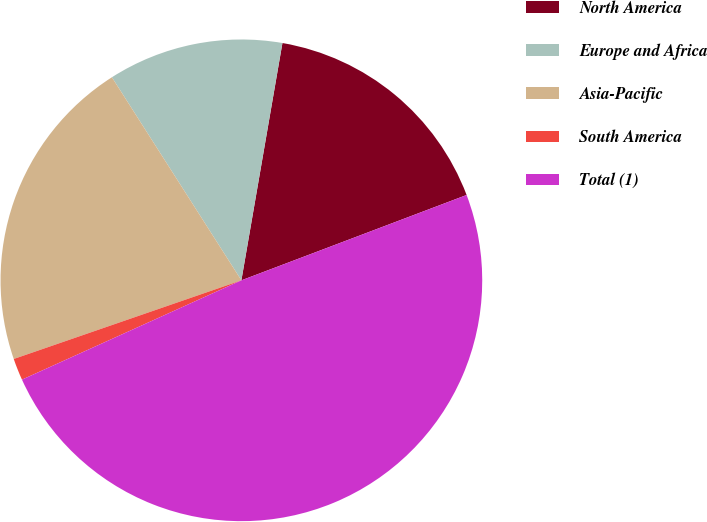<chart> <loc_0><loc_0><loc_500><loc_500><pie_chart><fcel>North America<fcel>Europe and Africa<fcel>Asia-Pacific<fcel>South America<fcel>Total (1)<nl><fcel>16.51%<fcel>11.76%<fcel>21.26%<fcel>1.47%<fcel>49.0%<nl></chart> 